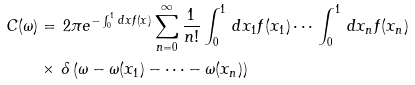Convert formula to latex. <formula><loc_0><loc_0><loc_500><loc_500>C ( \omega ) & = \, 2 \pi e ^ { - \int _ { 0 } ^ { 1 } \, d x f ( x ) } \sum _ { n = 0 } ^ { \infty } \frac { 1 } { n ! } \int _ { 0 } ^ { 1 } \, d x _ { 1 } f ( x _ { 1 } ) \cdots \, \int _ { 0 } ^ { 1 } \, d x _ { n } f ( x _ { n } ) \\ & \times \, \delta \left ( \omega - \omega ( x _ { 1 } ) - \cdots - \omega ( x _ { n } ) \right )</formula> 